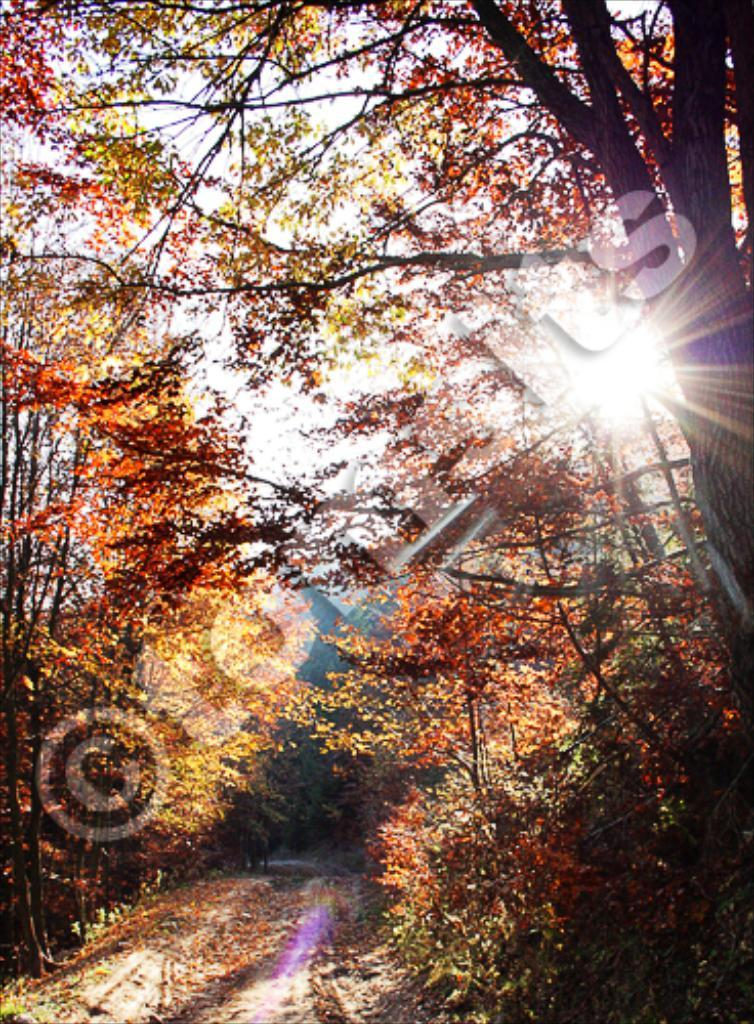What type of vegetation can be seen in the image? There are trees in the image. What is visible at the top of the image? The sky is visible at the top of the image. What is visible at the bottom of the image? The ground is visible at the bottom of the image. How many mice are sitting on the tree in the image? There are no mice present in the image; it only features trees. What type of drink is being served in the image? There is no drink present in the image. 